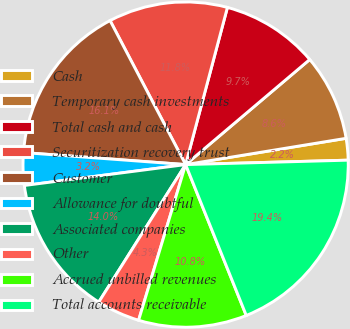Convert chart. <chart><loc_0><loc_0><loc_500><loc_500><pie_chart><fcel>Cash<fcel>Temporary cash investments<fcel>Total cash and cash<fcel>Securitization recovery trust<fcel>Customer<fcel>Allowance for doubtful<fcel>Associated companies<fcel>Other<fcel>Accrued unbilled revenues<fcel>Total accounts receivable<nl><fcel>2.15%<fcel>8.6%<fcel>9.68%<fcel>11.83%<fcel>16.13%<fcel>3.23%<fcel>13.98%<fcel>4.3%<fcel>10.75%<fcel>19.35%<nl></chart> 